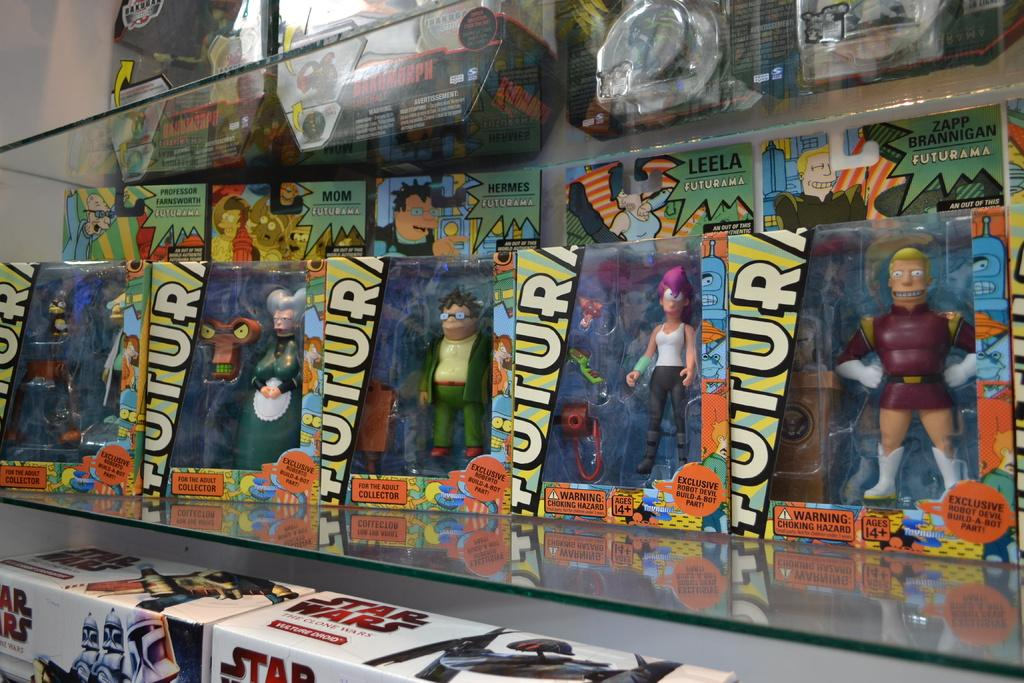<image>
Summarize the visual content of the image. A line of futurama toys on a shelf above star wars toys. 